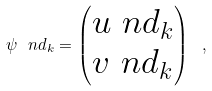<formula> <loc_0><loc_0><loc_500><loc_500>\psi \ n d _ { k } = \begin{pmatrix} u \ n d _ { k } \\ v \ n d _ { k } \end{pmatrix} \ ,</formula> 